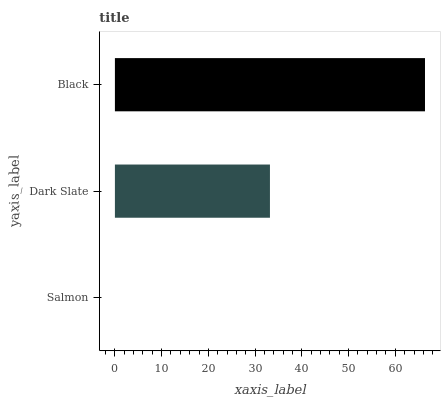Is Salmon the minimum?
Answer yes or no. Yes. Is Black the maximum?
Answer yes or no. Yes. Is Dark Slate the minimum?
Answer yes or no. No. Is Dark Slate the maximum?
Answer yes or no. No. Is Dark Slate greater than Salmon?
Answer yes or no. Yes. Is Salmon less than Dark Slate?
Answer yes or no. Yes. Is Salmon greater than Dark Slate?
Answer yes or no. No. Is Dark Slate less than Salmon?
Answer yes or no. No. Is Dark Slate the high median?
Answer yes or no. Yes. Is Dark Slate the low median?
Answer yes or no. Yes. Is Salmon the high median?
Answer yes or no. No. Is Salmon the low median?
Answer yes or no. No. 